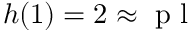<formula> <loc_0><loc_0><loc_500><loc_500>h ( 1 ) = 2 \approx p l</formula> 